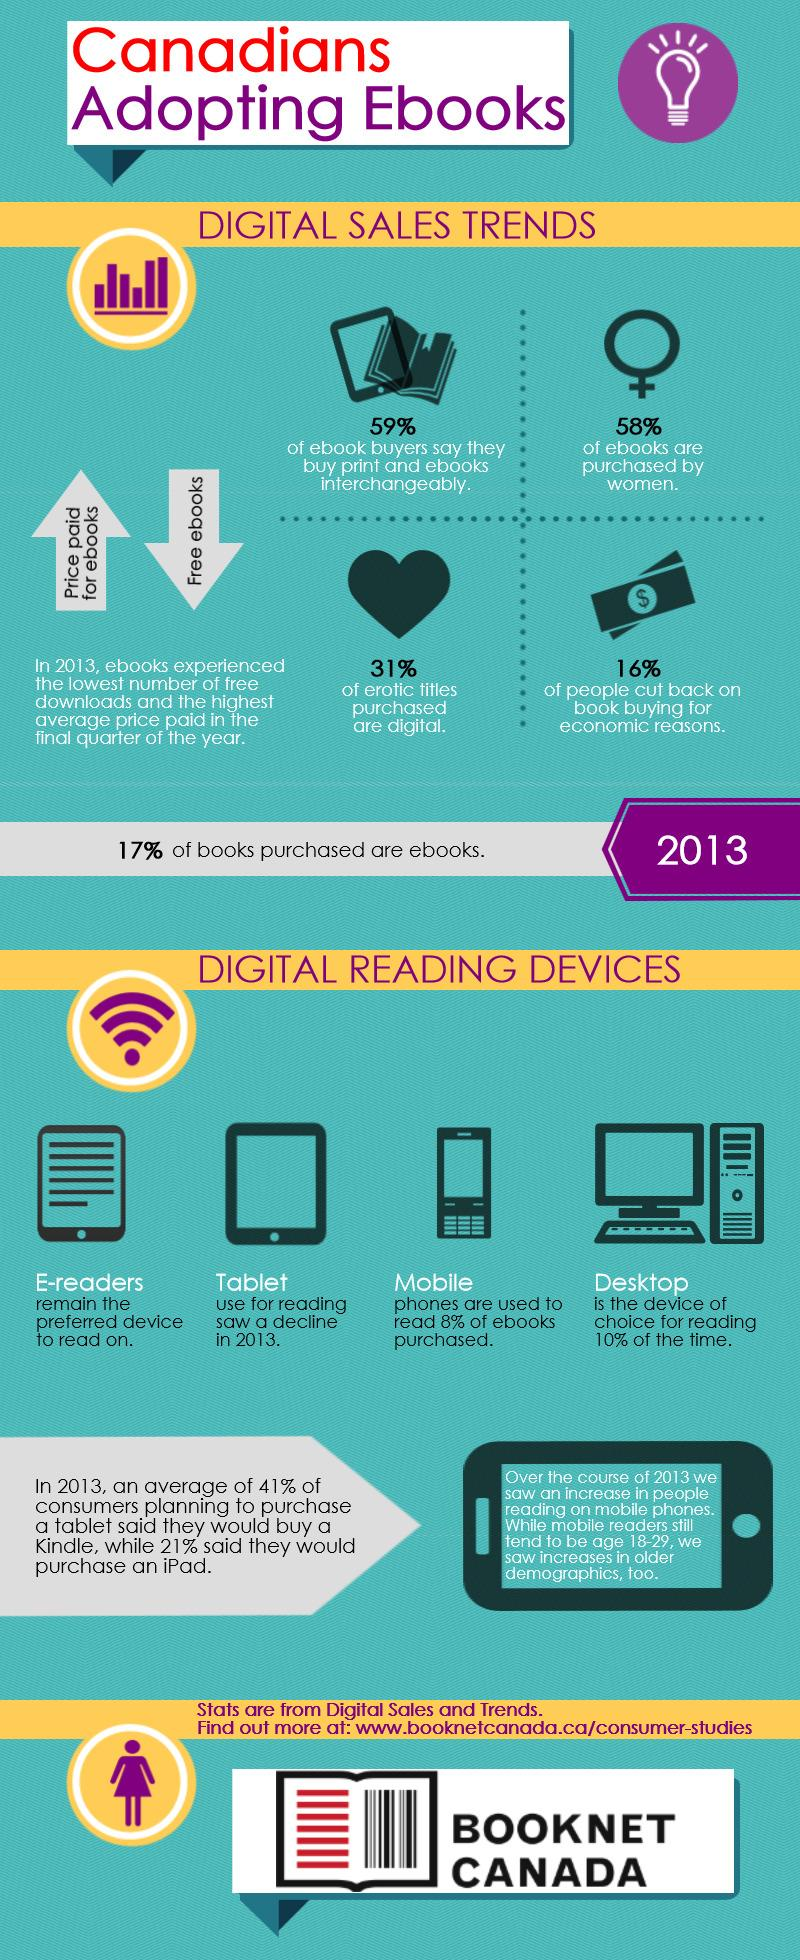Point out several critical features in this image. The inverse percentage of eBooks bought by females is 42%. In the year 2013, approximately 83% of eBooks were purchased. Desktop computers are the most commonly used devices for reading eBooks. 